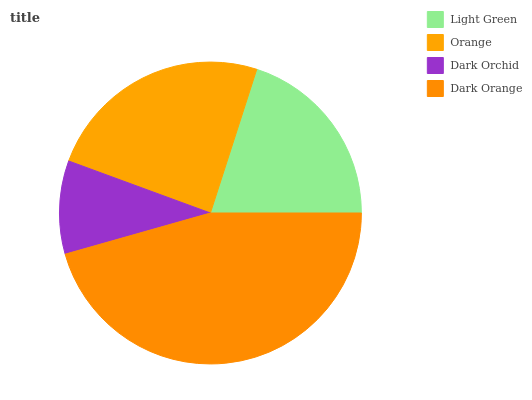Is Dark Orchid the minimum?
Answer yes or no. Yes. Is Dark Orange the maximum?
Answer yes or no. Yes. Is Orange the minimum?
Answer yes or no. No. Is Orange the maximum?
Answer yes or no. No. Is Orange greater than Light Green?
Answer yes or no. Yes. Is Light Green less than Orange?
Answer yes or no. Yes. Is Light Green greater than Orange?
Answer yes or no. No. Is Orange less than Light Green?
Answer yes or no. No. Is Orange the high median?
Answer yes or no. Yes. Is Light Green the low median?
Answer yes or no. Yes. Is Dark Orange the high median?
Answer yes or no. No. Is Orange the low median?
Answer yes or no. No. 